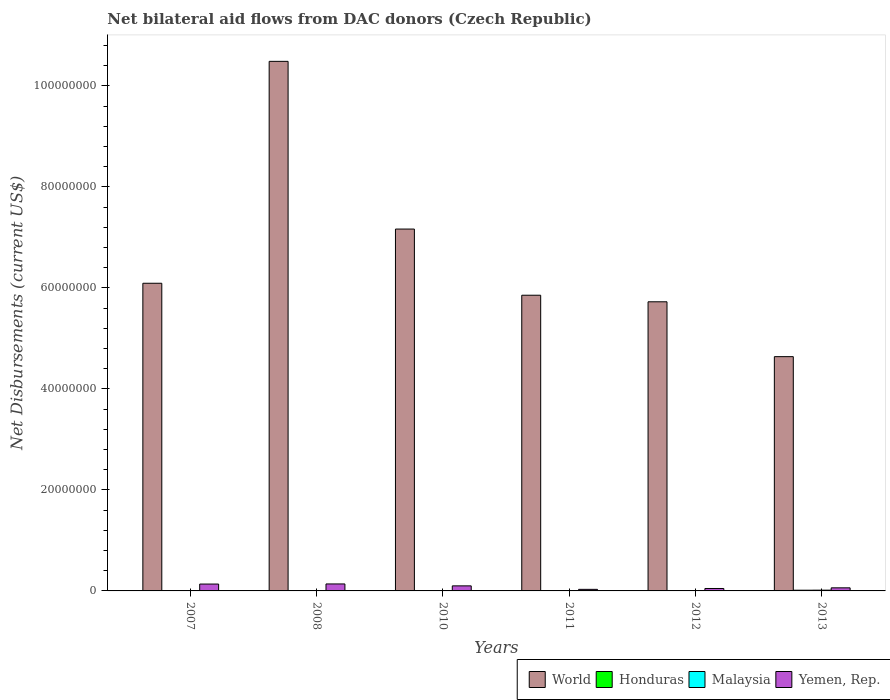How many groups of bars are there?
Give a very brief answer. 6. Are the number of bars per tick equal to the number of legend labels?
Your answer should be compact. Yes. How many bars are there on the 2nd tick from the left?
Keep it short and to the point. 4. How many bars are there on the 1st tick from the right?
Ensure brevity in your answer.  4. What is the label of the 2nd group of bars from the left?
Provide a short and direct response. 2008. In how many cases, is the number of bars for a given year not equal to the number of legend labels?
Your answer should be compact. 0. What is the net bilateral aid flows in World in 2010?
Offer a very short reply. 7.16e+07. Across all years, what is the maximum net bilateral aid flows in Yemen, Rep.?
Provide a short and direct response. 1.38e+06. Across all years, what is the minimum net bilateral aid flows in Yemen, Rep.?
Provide a succinct answer. 3.10e+05. What is the total net bilateral aid flows in Honduras in the graph?
Offer a terse response. 3.10e+05. What is the difference between the net bilateral aid flows in Yemen, Rep. in 2007 and the net bilateral aid flows in Honduras in 2012?
Your response must be concise. 1.34e+06. What is the average net bilateral aid flows in World per year?
Make the answer very short. 6.66e+07. In the year 2007, what is the difference between the net bilateral aid flows in Yemen, Rep. and net bilateral aid flows in Honduras?
Provide a short and direct response. 1.32e+06. In how many years, is the net bilateral aid flows in World greater than 12000000 US$?
Make the answer very short. 6. What is the ratio of the net bilateral aid flows in Malaysia in 2012 to that in 2013?
Offer a terse response. 0.33. Is the difference between the net bilateral aid flows in Yemen, Rep. in 2008 and 2012 greater than the difference between the net bilateral aid flows in Honduras in 2008 and 2012?
Offer a terse response. Yes. What is the difference between the highest and the lowest net bilateral aid flows in World?
Provide a succinct answer. 5.85e+07. Is the sum of the net bilateral aid flows in Honduras in 2010 and 2012 greater than the maximum net bilateral aid flows in Yemen, Rep. across all years?
Offer a very short reply. No. What does the 1st bar from the left in 2012 represents?
Make the answer very short. World. What does the 2nd bar from the right in 2012 represents?
Your response must be concise. Malaysia. How many bars are there?
Your answer should be compact. 24. How many years are there in the graph?
Offer a terse response. 6. What is the difference between two consecutive major ticks on the Y-axis?
Keep it short and to the point. 2.00e+07. Are the values on the major ticks of Y-axis written in scientific E-notation?
Make the answer very short. No. Does the graph contain any zero values?
Ensure brevity in your answer.  No. Does the graph contain grids?
Your answer should be compact. No. Where does the legend appear in the graph?
Your answer should be very brief. Bottom right. How are the legend labels stacked?
Ensure brevity in your answer.  Horizontal. What is the title of the graph?
Make the answer very short. Net bilateral aid flows from DAC donors (Czech Republic). What is the label or title of the X-axis?
Provide a succinct answer. Years. What is the label or title of the Y-axis?
Your answer should be compact. Net Disbursements (current US$). What is the Net Disbursements (current US$) in World in 2007?
Your answer should be very brief. 6.09e+07. What is the Net Disbursements (current US$) of Yemen, Rep. in 2007?
Give a very brief answer. 1.36e+06. What is the Net Disbursements (current US$) in World in 2008?
Offer a terse response. 1.05e+08. What is the Net Disbursements (current US$) in Yemen, Rep. in 2008?
Give a very brief answer. 1.38e+06. What is the Net Disbursements (current US$) of World in 2010?
Keep it short and to the point. 7.16e+07. What is the Net Disbursements (current US$) of Honduras in 2010?
Ensure brevity in your answer.  3.00e+04. What is the Net Disbursements (current US$) of Yemen, Rep. in 2010?
Your answer should be compact. 1.00e+06. What is the Net Disbursements (current US$) in World in 2011?
Offer a very short reply. 5.85e+07. What is the Net Disbursements (current US$) of Honduras in 2011?
Keep it short and to the point. 4.00e+04. What is the Net Disbursements (current US$) in Yemen, Rep. in 2011?
Give a very brief answer. 3.10e+05. What is the Net Disbursements (current US$) in World in 2012?
Your response must be concise. 5.72e+07. What is the Net Disbursements (current US$) of Yemen, Rep. in 2012?
Make the answer very short. 4.80e+05. What is the Net Disbursements (current US$) of World in 2013?
Your answer should be compact. 4.64e+07. What is the Net Disbursements (current US$) in Malaysia in 2013?
Keep it short and to the point. 1.50e+05. Across all years, what is the maximum Net Disbursements (current US$) of World?
Your answer should be very brief. 1.05e+08. Across all years, what is the maximum Net Disbursements (current US$) of Honduras?
Provide a short and direct response. 1.40e+05. Across all years, what is the maximum Net Disbursements (current US$) in Yemen, Rep.?
Provide a short and direct response. 1.38e+06. Across all years, what is the minimum Net Disbursements (current US$) of World?
Your answer should be very brief. 4.64e+07. Across all years, what is the minimum Net Disbursements (current US$) in Honduras?
Make the answer very short. 2.00e+04. Across all years, what is the minimum Net Disbursements (current US$) of Malaysia?
Your response must be concise. 2.00e+04. What is the total Net Disbursements (current US$) of World in the graph?
Your answer should be very brief. 4.00e+08. What is the total Net Disbursements (current US$) of Yemen, Rep. in the graph?
Ensure brevity in your answer.  5.14e+06. What is the difference between the Net Disbursements (current US$) of World in 2007 and that in 2008?
Provide a succinct answer. -4.39e+07. What is the difference between the Net Disbursements (current US$) in Honduras in 2007 and that in 2008?
Provide a short and direct response. 0. What is the difference between the Net Disbursements (current US$) of Malaysia in 2007 and that in 2008?
Make the answer very short. -10000. What is the difference between the Net Disbursements (current US$) in Yemen, Rep. in 2007 and that in 2008?
Offer a very short reply. -2.00e+04. What is the difference between the Net Disbursements (current US$) in World in 2007 and that in 2010?
Your answer should be compact. -1.07e+07. What is the difference between the Net Disbursements (current US$) in Honduras in 2007 and that in 2010?
Your answer should be very brief. 10000. What is the difference between the Net Disbursements (current US$) of Malaysia in 2007 and that in 2010?
Give a very brief answer. -4.00e+04. What is the difference between the Net Disbursements (current US$) of Yemen, Rep. in 2007 and that in 2010?
Your response must be concise. 3.60e+05. What is the difference between the Net Disbursements (current US$) in World in 2007 and that in 2011?
Your answer should be very brief. 2.37e+06. What is the difference between the Net Disbursements (current US$) of Yemen, Rep. in 2007 and that in 2011?
Keep it short and to the point. 1.05e+06. What is the difference between the Net Disbursements (current US$) of World in 2007 and that in 2012?
Offer a terse response. 3.67e+06. What is the difference between the Net Disbursements (current US$) in Malaysia in 2007 and that in 2012?
Provide a short and direct response. -3.00e+04. What is the difference between the Net Disbursements (current US$) of Yemen, Rep. in 2007 and that in 2012?
Offer a very short reply. 8.80e+05. What is the difference between the Net Disbursements (current US$) in World in 2007 and that in 2013?
Offer a very short reply. 1.45e+07. What is the difference between the Net Disbursements (current US$) in Malaysia in 2007 and that in 2013?
Provide a succinct answer. -1.30e+05. What is the difference between the Net Disbursements (current US$) in Yemen, Rep. in 2007 and that in 2013?
Provide a succinct answer. 7.50e+05. What is the difference between the Net Disbursements (current US$) of World in 2008 and that in 2010?
Ensure brevity in your answer.  3.32e+07. What is the difference between the Net Disbursements (current US$) in Honduras in 2008 and that in 2010?
Keep it short and to the point. 10000. What is the difference between the Net Disbursements (current US$) of World in 2008 and that in 2011?
Give a very brief answer. 4.63e+07. What is the difference between the Net Disbursements (current US$) of Malaysia in 2008 and that in 2011?
Keep it short and to the point. -3.00e+04. What is the difference between the Net Disbursements (current US$) in Yemen, Rep. in 2008 and that in 2011?
Offer a very short reply. 1.07e+06. What is the difference between the Net Disbursements (current US$) in World in 2008 and that in 2012?
Keep it short and to the point. 4.76e+07. What is the difference between the Net Disbursements (current US$) of Malaysia in 2008 and that in 2012?
Your response must be concise. -2.00e+04. What is the difference between the Net Disbursements (current US$) of Yemen, Rep. in 2008 and that in 2012?
Ensure brevity in your answer.  9.00e+05. What is the difference between the Net Disbursements (current US$) of World in 2008 and that in 2013?
Offer a terse response. 5.85e+07. What is the difference between the Net Disbursements (current US$) in Honduras in 2008 and that in 2013?
Ensure brevity in your answer.  -1.00e+05. What is the difference between the Net Disbursements (current US$) in Yemen, Rep. in 2008 and that in 2013?
Offer a terse response. 7.70e+05. What is the difference between the Net Disbursements (current US$) in World in 2010 and that in 2011?
Your response must be concise. 1.31e+07. What is the difference between the Net Disbursements (current US$) of Yemen, Rep. in 2010 and that in 2011?
Your answer should be compact. 6.90e+05. What is the difference between the Net Disbursements (current US$) in World in 2010 and that in 2012?
Your response must be concise. 1.44e+07. What is the difference between the Net Disbursements (current US$) of Honduras in 2010 and that in 2012?
Provide a succinct answer. 10000. What is the difference between the Net Disbursements (current US$) in Malaysia in 2010 and that in 2012?
Your answer should be compact. 10000. What is the difference between the Net Disbursements (current US$) of Yemen, Rep. in 2010 and that in 2012?
Ensure brevity in your answer.  5.20e+05. What is the difference between the Net Disbursements (current US$) of World in 2010 and that in 2013?
Provide a succinct answer. 2.53e+07. What is the difference between the Net Disbursements (current US$) of Honduras in 2010 and that in 2013?
Ensure brevity in your answer.  -1.10e+05. What is the difference between the Net Disbursements (current US$) in World in 2011 and that in 2012?
Provide a short and direct response. 1.30e+06. What is the difference between the Net Disbursements (current US$) of Honduras in 2011 and that in 2012?
Offer a very short reply. 2.00e+04. What is the difference between the Net Disbursements (current US$) in World in 2011 and that in 2013?
Provide a succinct answer. 1.22e+07. What is the difference between the Net Disbursements (current US$) of Malaysia in 2011 and that in 2013?
Your response must be concise. -9.00e+04. What is the difference between the Net Disbursements (current US$) of Yemen, Rep. in 2011 and that in 2013?
Your answer should be compact. -3.00e+05. What is the difference between the Net Disbursements (current US$) of World in 2012 and that in 2013?
Ensure brevity in your answer.  1.09e+07. What is the difference between the Net Disbursements (current US$) of Honduras in 2012 and that in 2013?
Provide a succinct answer. -1.20e+05. What is the difference between the Net Disbursements (current US$) of Malaysia in 2012 and that in 2013?
Offer a terse response. -1.00e+05. What is the difference between the Net Disbursements (current US$) in World in 2007 and the Net Disbursements (current US$) in Honduras in 2008?
Give a very brief answer. 6.09e+07. What is the difference between the Net Disbursements (current US$) of World in 2007 and the Net Disbursements (current US$) of Malaysia in 2008?
Your response must be concise. 6.09e+07. What is the difference between the Net Disbursements (current US$) in World in 2007 and the Net Disbursements (current US$) in Yemen, Rep. in 2008?
Provide a succinct answer. 5.95e+07. What is the difference between the Net Disbursements (current US$) in Honduras in 2007 and the Net Disbursements (current US$) in Yemen, Rep. in 2008?
Offer a very short reply. -1.34e+06. What is the difference between the Net Disbursements (current US$) in Malaysia in 2007 and the Net Disbursements (current US$) in Yemen, Rep. in 2008?
Offer a very short reply. -1.36e+06. What is the difference between the Net Disbursements (current US$) of World in 2007 and the Net Disbursements (current US$) of Honduras in 2010?
Your response must be concise. 6.09e+07. What is the difference between the Net Disbursements (current US$) of World in 2007 and the Net Disbursements (current US$) of Malaysia in 2010?
Offer a very short reply. 6.08e+07. What is the difference between the Net Disbursements (current US$) in World in 2007 and the Net Disbursements (current US$) in Yemen, Rep. in 2010?
Your answer should be very brief. 5.99e+07. What is the difference between the Net Disbursements (current US$) in Honduras in 2007 and the Net Disbursements (current US$) in Malaysia in 2010?
Give a very brief answer. -2.00e+04. What is the difference between the Net Disbursements (current US$) in Honduras in 2007 and the Net Disbursements (current US$) in Yemen, Rep. in 2010?
Provide a succinct answer. -9.60e+05. What is the difference between the Net Disbursements (current US$) in Malaysia in 2007 and the Net Disbursements (current US$) in Yemen, Rep. in 2010?
Your response must be concise. -9.80e+05. What is the difference between the Net Disbursements (current US$) of World in 2007 and the Net Disbursements (current US$) of Honduras in 2011?
Ensure brevity in your answer.  6.09e+07. What is the difference between the Net Disbursements (current US$) of World in 2007 and the Net Disbursements (current US$) of Malaysia in 2011?
Your answer should be compact. 6.08e+07. What is the difference between the Net Disbursements (current US$) of World in 2007 and the Net Disbursements (current US$) of Yemen, Rep. in 2011?
Give a very brief answer. 6.06e+07. What is the difference between the Net Disbursements (current US$) of World in 2007 and the Net Disbursements (current US$) of Honduras in 2012?
Give a very brief answer. 6.09e+07. What is the difference between the Net Disbursements (current US$) of World in 2007 and the Net Disbursements (current US$) of Malaysia in 2012?
Offer a very short reply. 6.09e+07. What is the difference between the Net Disbursements (current US$) of World in 2007 and the Net Disbursements (current US$) of Yemen, Rep. in 2012?
Your answer should be very brief. 6.04e+07. What is the difference between the Net Disbursements (current US$) in Honduras in 2007 and the Net Disbursements (current US$) in Malaysia in 2012?
Provide a short and direct response. -10000. What is the difference between the Net Disbursements (current US$) of Honduras in 2007 and the Net Disbursements (current US$) of Yemen, Rep. in 2012?
Your answer should be compact. -4.40e+05. What is the difference between the Net Disbursements (current US$) in Malaysia in 2007 and the Net Disbursements (current US$) in Yemen, Rep. in 2012?
Your answer should be very brief. -4.60e+05. What is the difference between the Net Disbursements (current US$) of World in 2007 and the Net Disbursements (current US$) of Honduras in 2013?
Offer a very short reply. 6.08e+07. What is the difference between the Net Disbursements (current US$) of World in 2007 and the Net Disbursements (current US$) of Malaysia in 2013?
Give a very brief answer. 6.08e+07. What is the difference between the Net Disbursements (current US$) of World in 2007 and the Net Disbursements (current US$) of Yemen, Rep. in 2013?
Offer a terse response. 6.03e+07. What is the difference between the Net Disbursements (current US$) of Honduras in 2007 and the Net Disbursements (current US$) of Malaysia in 2013?
Keep it short and to the point. -1.10e+05. What is the difference between the Net Disbursements (current US$) in Honduras in 2007 and the Net Disbursements (current US$) in Yemen, Rep. in 2013?
Your response must be concise. -5.70e+05. What is the difference between the Net Disbursements (current US$) of Malaysia in 2007 and the Net Disbursements (current US$) of Yemen, Rep. in 2013?
Offer a terse response. -5.90e+05. What is the difference between the Net Disbursements (current US$) of World in 2008 and the Net Disbursements (current US$) of Honduras in 2010?
Your answer should be compact. 1.05e+08. What is the difference between the Net Disbursements (current US$) in World in 2008 and the Net Disbursements (current US$) in Malaysia in 2010?
Your response must be concise. 1.05e+08. What is the difference between the Net Disbursements (current US$) of World in 2008 and the Net Disbursements (current US$) of Yemen, Rep. in 2010?
Your response must be concise. 1.04e+08. What is the difference between the Net Disbursements (current US$) in Honduras in 2008 and the Net Disbursements (current US$) in Malaysia in 2010?
Offer a terse response. -2.00e+04. What is the difference between the Net Disbursements (current US$) of Honduras in 2008 and the Net Disbursements (current US$) of Yemen, Rep. in 2010?
Ensure brevity in your answer.  -9.60e+05. What is the difference between the Net Disbursements (current US$) of Malaysia in 2008 and the Net Disbursements (current US$) of Yemen, Rep. in 2010?
Give a very brief answer. -9.70e+05. What is the difference between the Net Disbursements (current US$) in World in 2008 and the Net Disbursements (current US$) in Honduras in 2011?
Provide a succinct answer. 1.05e+08. What is the difference between the Net Disbursements (current US$) of World in 2008 and the Net Disbursements (current US$) of Malaysia in 2011?
Provide a short and direct response. 1.05e+08. What is the difference between the Net Disbursements (current US$) of World in 2008 and the Net Disbursements (current US$) of Yemen, Rep. in 2011?
Offer a terse response. 1.05e+08. What is the difference between the Net Disbursements (current US$) in Honduras in 2008 and the Net Disbursements (current US$) in Malaysia in 2011?
Provide a succinct answer. -2.00e+04. What is the difference between the Net Disbursements (current US$) of Malaysia in 2008 and the Net Disbursements (current US$) of Yemen, Rep. in 2011?
Your answer should be very brief. -2.80e+05. What is the difference between the Net Disbursements (current US$) of World in 2008 and the Net Disbursements (current US$) of Honduras in 2012?
Ensure brevity in your answer.  1.05e+08. What is the difference between the Net Disbursements (current US$) of World in 2008 and the Net Disbursements (current US$) of Malaysia in 2012?
Provide a short and direct response. 1.05e+08. What is the difference between the Net Disbursements (current US$) of World in 2008 and the Net Disbursements (current US$) of Yemen, Rep. in 2012?
Give a very brief answer. 1.04e+08. What is the difference between the Net Disbursements (current US$) in Honduras in 2008 and the Net Disbursements (current US$) in Malaysia in 2012?
Your answer should be compact. -10000. What is the difference between the Net Disbursements (current US$) of Honduras in 2008 and the Net Disbursements (current US$) of Yemen, Rep. in 2012?
Make the answer very short. -4.40e+05. What is the difference between the Net Disbursements (current US$) in Malaysia in 2008 and the Net Disbursements (current US$) in Yemen, Rep. in 2012?
Ensure brevity in your answer.  -4.50e+05. What is the difference between the Net Disbursements (current US$) in World in 2008 and the Net Disbursements (current US$) in Honduras in 2013?
Keep it short and to the point. 1.05e+08. What is the difference between the Net Disbursements (current US$) of World in 2008 and the Net Disbursements (current US$) of Malaysia in 2013?
Offer a terse response. 1.05e+08. What is the difference between the Net Disbursements (current US$) of World in 2008 and the Net Disbursements (current US$) of Yemen, Rep. in 2013?
Make the answer very short. 1.04e+08. What is the difference between the Net Disbursements (current US$) in Honduras in 2008 and the Net Disbursements (current US$) in Yemen, Rep. in 2013?
Your answer should be compact. -5.70e+05. What is the difference between the Net Disbursements (current US$) of Malaysia in 2008 and the Net Disbursements (current US$) of Yemen, Rep. in 2013?
Keep it short and to the point. -5.80e+05. What is the difference between the Net Disbursements (current US$) of World in 2010 and the Net Disbursements (current US$) of Honduras in 2011?
Provide a short and direct response. 7.16e+07. What is the difference between the Net Disbursements (current US$) of World in 2010 and the Net Disbursements (current US$) of Malaysia in 2011?
Your response must be concise. 7.16e+07. What is the difference between the Net Disbursements (current US$) in World in 2010 and the Net Disbursements (current US$) in Yemen, Rep. in 2011?
Ensure brevity in your answer.  7.13e+07. What is the difference between the Net Disbursements (current US$) of Honduras in 2010 and the Net Disbursements (current US$) of Malaysia in 2011?
Provide a short and direct response. -3.00e+04. What is the difference between the Net Disbursements (current US$) of Honduras in 2010 and the Net Disbursements (current US$) of Yemen, Rep. in 2011?
Keep it short and to the point. -2.80e+05. What is the difference between the Net Disbursements (current US$) of World in 2010 and the Net Disbursements (current US$) of Honduras in 2012?
Offer a terse response. 7.16e+07. What is the difference between the Net Disbursements (current US$) in World in 2010 and the Net Disbursements (current US$) in Malaysia in 2012?
Offer a terse response. 7.16e+07. What is the difference between the Net Disbursements (current US$) of World in 2010 and the Net Disbursements (current US$) of Yemen, Rep. in 2012?
Provide a succinct answer. 7.12e+07. What is the difference between the Net Disbursements (current US$) of Honduras in 2010 and the Net Disbursements (current US$) of Malaysia in 2012?
Provide a short and direct response. -2.00e+04. What is the difference between the Net Disbursements (current US$) of Honduras in 2010 and the Net Disbursements (current US$) of Yemen, Rep. in 2012?
Your answer should be compact. -4.50e+05. What is the difference between the Net Disbursements (current US$) in Malaysia in 2010 and the Net Disbursements (current US$) in Yemen, Rep. in 2012?
Keep it short and to the point. -4.20e+05. What is the difference between the Net Disbursements (current US$) of World in 2010 and the Net Disbursements (current US$) of Honduras in 2013?
Your answer should be compact. 7.15e+07. What is the difference between the Net Disbursements (current US$) of World in 2010 and the Net Disbursements (current US$) of Malaysia in 2013?
Offer a terse response. 7.15e+07. What is the difference between the Net Disbursements (current US$) in World in 2010 and the Net Disbursements (current US$) in Yemen, Rep. in 2013?
Offer a terse response. 7.10e+07. What is the difference between the Net Disbursements (current US$) in Honduras in 2010 and the Net Disbursements (current US$) in Yemen, Rep. in 2013?
Your response must be concise. -5.80e+05. What is the difference between the Net Disbursements (current US$) in Malaysia in 2010 and the Net Disbursements (current US$) in Yemen, Rep. in 2013?
Make the answer very short. -5.50e+05. What is the difference between the Net Disbursements (current US$) in World in 2011 and the Net Disbursements (current US$) in Honduras in 2012?
Provide a succinct answer. 5.85e+07. What is the difference between the Net Disbursements (current US$) of World in 2011 and the Net Disbursements (current US$) of Malaysia in 2012?
Keep it short and to the point. 5.85e+07. What is the difference between the Net Disbursements (current US$) of World in 2011 and the Net Disbursements (current US$) of Yemen, Rep. in 2012?
Your response must be concise. 5.81e+07. What is the difference between the Net Disbursements (current US$) in Honduras in 2011 and the Net Disbursements (current US$) in Malaysia in 2012?
Provide a succinct answer. -10000. What is the difference between the Net Disbursements (current US$) in Honduras in 2011 and the Net Disbursements (current US$) in Yemen, Rep. in 2012?
Provide a short and direct response. -4.40e+05. What is the difference between the Net Disbursements (current US$) in Malaysia in 2011 and the Net Disbursements (current US$) in Yemen, Rep. in 2012?
Ensure brevity in your answer.  -4.20e+05. What is the difference between the Net Disbursements (current US$) of World in 2011 and the Net Disbursements (current US$) of Honduras in 2013?
Keep it short and to the point. 5.84e+07. What is the difference between the Net Disbursements (current US$) in World in 2011 and the Net Disbursements (current US$) in Malaysia in 2013?
Give a very brief answer. 5.84e+07. What is the difference between the Net Disbursements (current US$) in World in 2011 and the Net Disbursements (current US$) in Yemen, Rep. in 2013?
Keep it short and to the point. 5.79e+07. What is the difference between the Net Disbursements (current US$) of Honduras in 2011 and the Net Disbursements (current US$) of Malaysia in 2013?
Offer a very short reply. -1.10e+05. What is the difference between the Net Disbursements (current US$) of Honduras in 2011 and the Net Disbursements (current US$) of Yemen, Rep. in 2013?
Give a very brief answer. -5.70e+05. What is the difference between the Net Disbursements (current US$) in Malaysia in 2011 and the Net Disbursements (current US$) in Yemen, Rep. in 2013?
Your answer should be compact. -5.50e+05. What is the difference between the Net Disbursements (current US$) in World in 2012 and the Net Disbursements (current US$) in Honduras in 2013?
Your response must be concise. 5.71e+07. What is the difference between the Net Disbursements (current US$) in World in 2012 and the Net Disbursements (current US$) in Malaysia in 2013?
Make the answer very short. 5.71e+07. What is the difference between the Net Disbursements (current US$) in World in 2012 and the Net Disbursements (current US$) in Yemen, Rep. in 2013?
Your answer should be compact. 5.66e+07. What is the difference between the Net Disbursements (current US$) of Honduras in 2012 and the Net Disbursements (current US$) of Malaysia in 2013?
Keep it short and to the point. -1.30e+05. What is the difference between the Net Disbursements (current US$) of Honduras in 2012 and the Net Disbursements (current US$) of Yemen, Rep. in 2013?
Provide a succinct answer. -5.90e+05. What is the difference between the Net Disbursements (current US$) in Malaysia in 2012 and the Net Disbursements (current US$) in Yemen, Rep. in 2013?
Provide a succinct answer. -5.60e+05. What is the average Net Disbursements (current US$) of World per year?
Ensure brevity in your answer.  6.66e+07. What is the average Net Disbursements (current US$) in Honduras per year?
Your answer should be compact. 5.17e+04. What is the average Net Disbursements (current US$) in Malaysia per year?
Offer a very short reply. 6.17e+04. What is the average Net Disbursements (current US$) in Yemen, Rep. per year?
Provide a short and direct response. 8.57e+05. In the year 2007, what is the difference between the Net Disbursements (current US$) in World and Net Disbursements (current US$) in Honduras?
Offer a very short reply. 6.09e+07. In the year 2007, what is the difference between the Net Disbursements (current US$) in World and Net Disbursements (current US$) in Malaysia?
Your response must be concise. 6.09e+07. In the year 2007, what is the difference between the Net Disbursements (current US$) of World and Net Disbursements (current US$) of Yemen, Rep.?
Offer a terse response. 5.96e+07. In the year 2007, what is the difference between the Net Disbursements (current US$) in Honduras and Net Disbursements (current US$) in Malaysia?
Your answer should be compact. 2.00e+04. In the year 2007, what is the difference between the Net Disbursements (current US$) of Honduras and Net Disbursements (current US$) of Yemen, Rep.?
Ensure brevity in your answer.  -1.32e+06. In the year 2007, what is the difference between the Net Disbursements (current US$) of Malaysia and Net Disbursements (current US$) of Yemen, Rep.?
Give a very brief answer. -1.34e+06. In the year 2008, what is the difference between the Net Disbursements (current US$) in World and Net Disbursements (current US$) in Honduras?
Your answer should be very brief. 1.05e+08. In the year 2008, what is the difference between the Net Disbursements (current US$) in World and Net Disbursements (current US$) in Malaysia?
Your answer should be very brief. 1.05e+08. In the year 2008, what is the difference between the Net Disbursements (current US$) in World and Net Disbursements (current US$) in Yemen, Rep.?
Offer a terse response. 1.03e+08. In the year 2008, what is the difference between the Net Disbursements (current US$) of Honduras and Net Disbursements (current US$) of Malaysia?
Your answer should be compact. 10000. In the year 2008, what is the difference between the Net Disbursements (current US$) of Honduras and Net Disbursements (current US$) of Yemen, Rep.?
Offer a very short reply. -1.34e+06. In the year 2008, what is the difference between the Net Disbursements (current US$) in Malaysia and Net Disbursements (current US$) in Yemen, Rep.?
Your response must be concise. -1.35e+06. In the year 2010, what is the difference between the Net Disbursements (current US$) of World and Net Disbursements (current US$) of Honduras?
Provide a short and direct response. 7.16e+07. In the year 2010, what is the difference between the Net Disbursements (current US$) in World and Net Disbursements (current US$) in Malaysia?
Your answer should be very brief. 7.16e+07. In the year 2010, what is the difference between the Net Disbursements (current US$) in World and Net Disbursements (current US$) in Yemen, Rep.?
Your answer should be very brief. 7.06e+07. In the year 2010, what is the difference between the Net Disbursements (current US$) in Honduras and Net Disbursements (current US$) in Malaysia?
Make the answer very short. -3.00e+04. In the year 2010, what is the difference between the Net Disbursements (current US$) in Honduras and Net Disbursements (current US$) in Yemen, Rep.?
Make the answer very short. -9.70e+05. In the year 2010, what is the difference between the Net Disbursements (current US$) of Malaysia and Net Disbursements (current US$) of Yemen, Rep.?
Offer a very short reply. -9.40e+05. In the year 2011, what is the difference between the Net Disbursements (current US$) of World and Net Disbursements (current US$) of Honduras?
Keep it short and to the point. 5.85e+07. In the year 2011, what is the difference between the Net Disbursements (current US$) in World and Net Disbursements (current US$) in Malaysia?
Provide a short and direct response. 5.85e+07. In the year 2011, what is the difference between the Net Disbursements (current US$) in World and Net Disbursements (current US$) in Yemen, Rep.?
Provide a succinct answer. 5.82e+07. In the year 2011, what is the difference between the Net Disbursements (current US$) in Honduras and Net Disbursements (current US$) in Malaysia?
Your answer should be compact. -2.00e+04. In the year 2011, what is the difference between the Net Disbursements (current US$) of Malaysia and Net Disbursements (current US$) of Yemen, Rep.?
Your response must be concise. -2.50e+05. In the year 2012, what is the difference between the Net Disbursements (current US$) of World and Net Disbursements (current US$) of Honduras?
Offer a terse response. 5.72e+07. In the year 2012, what is the difference between the Net Disbursements (current US$) of World and Net Disbursements (current US$) of Malaysia?
Your answer should be very brief. 5.72e+07. In the year 2012, what is the difference between the Net Disbursements (current US$) of World and Net Disbursements (current US$) of Yemen, Rep.?
Offer a very short reply. 5.68e+07. In the year 2012, what is the difference between the Net Disbursements (current US$) in Honduras and Net Disbursements (current US$) in Yemen, Rep.?
Provide a succinct answer. -4.60e+05. In the year 2012, what is the difference between the Net Disbursements (current US$) in Malaysia and Net Disbursements (current US$) in Yemen, Rep.?
Keep it short and to the point. -4.30e+05. In the year 2013, what is the difference between the Net Disbursements (current US$) in World and Net Disbursements (current US$) in Honduras?
Keep it short and to the point. 4.62e+07. In the year 2013, what is the difference between the Net Disbursements (current US$) in World and Net Disbursements (current US$) in Malaysia?
Offer a terse response. 4.62e+07. In the year 2013, what is the difference between the Net Disbursements (current US$) of World and Net Disbursements (current US$) of Yemen, Rep.?
Keep it short and to the point. 4.58e+07. In the year 2013, what is the difference between the Net Disbursements (current US$) in Honduras and Net Disbursements (current US$) in Malaysia?
Keep it short and to the point. -10000. In the year 2013, what is the difference between the Net Disbursements (current US$) of Honduras and Net Disbursements (current US$) of Yemen, Rep.?
Ensure brevity in your answer.  -4.70e+05. In the year 2013, what is the difference between the Net Disbursements (current US$) in Malaysia and Net Disbursements (current US$) in Yemen, Rep.?
Make the answer very short. -4.60e+05. What is the ratio of the Net Disbursements (current US$) in World in 2007 to that in 2008?
Ensure brevity in your answer.  0.58. What is the ratio of the Net Disbursements (current US$) of Honduras in 2007 to that in 2008?
Ensure brevity in your answer.  1. What is the ratio of the Net Disbursements (current US$) of Malaysia in 2007 to that in 2008?
Your response must be concise. 0.67. What is the ratio of the Net Disbursements (current US$) of Yemen, Rep. in 2007 to that in 2008?
Give a very brief answer. 0.99. What is the ratio of the Net Disbursements (current US$) in World in 2007 to that in 2010?
Your answer should be very brief. 0.85. What is the ratio of the Net Disbursements (current US$) of Honduras in 2007 to that in 2010?
Your answer should be very brief. 1.33. What is the ratio of the Net Disbursements (current US$) of Yemen, Rep. in 2007 to that in 2010?
Provide a short and direct response. 1.36. What is the ratio of the Net Disbursements (current US$) of World in 2007 to that in 2011?
Give a very brief answer. 1.04. What is the ratio of the Net Disbursements (current US$) of Malaysia in 2007 to that in 2011?
Your answer should be compact. 0.33. What is the ratio of the Net Disbursements (current US$) of Yemen, Rep. in 2007 to that in 2011?
Ensure brevity in your answer.  4.39. What is the ratio of the Net Disbursements (current US$) of World in 2007 to that in 2012?
Your response must be concise. 1.06. What is the ratio of the Net Disbursements (current US$) in Honduras in 2007 to that in 2012?
Provide a short and direct response. 2. What is the ratio of the Net Disbursements (current US$) in Yemen, Rep. in 2007 to that in 2012?
Keep it short and to the point. 2.83. What is the ratio of the Net Disbursements (current US$) of World in 2007 to that in 2013?
Offer a terse response. 1.31. What is the ratio of the Net Disbursements (current US$) in Honduras in 2007 to that in 2013?
Your answer should be compact. 0.29. What is the ratio of the Net Disbursements (current US$) in Malaysia in 2007 to that in 2013?
Your answer should be very brief. 0.13. What is the ratio of the Net Disbursements (current US$) in Yemen, Rep. in 2007 to that in 2013?
Provide a short and direct response. 2.23. What is the ratio of the Net Disbursements (current US$) in World in 2008 to that in 2010?
Your answer should be compact. 1.46. What is the ratio of the Net Disbursements (current US$) in Malaysia in 2008 to that in 2010?
Offer a terse response. 0.5. What is the ratio of the Net Disbursements (current US$) in Yemen, Rep. in 2008 to that in 2010?
Provide a succinct answer. 1.38. What is the ratio of the Net Disbursements (current US$) of World in 2008 to that in 2011?
Your response must be concise. 1.79. What is the ratio of the Net Disbursements (current US$) in Malaysia in 2008 to that in 2011?
Offer a very short reply. 0.5. What is the ratio of the Net Disbursements (current US$) of Yemen, Rep. in 2008 to that in 2011?
Give a very brief answer. 4.45. What is the ratio of the Net Disbursements (current US$) in World in 2008 to that in 2012?
Ensure brevity in your answer.  1.83. What is the ratio of the Net Disbursements (current US$) of Malaysia in 2008 to that in 2012?
Your answer should be compact. 0.6. What is the ratio of the Net Disbursements (current US$) in Yemen, Rep. in 2008 to that in 2012?
Your answer should be compact. 2.88. What is the ratio of the Net Disbursements (current US$) in World in 2008 to that in 2013?
Your answer should be compact. 2.26. What is the ratio of the Net Disbursements (current US$) of Honduras in 2008 to that in 2013?
Offer a very short reply. 0.29. What is the ratio of the Net Disbursements (current US$) in Yemen, Rep. in 2008 to that in 2013?
Keep it short and to the point. 2.26. What is the ratio of the Net Disbursements (current US$) in World in 2010 to that in 2011?
Your answer should be very brief. 1.22. What is the ratio of the Net Disbursements (current US$) of Malaysia in 2010 to that in 2011?
Your response must be concise. 1. What is the ratio of the Net Disbursements (current US$) of Yemen, Rep. in 2010 to that in 2011?
Offer a very short reply. 3.23. What is the ratio of the Net Disbursements (current US$) in World in 2010 to that in 2012?
Offer a terse response. 1.25. What is the ratio of the Net Disbursements (current US$) of Honduras in 2010 to that in 2012?
Your answer should be very brief. 1.5. What is the ratio of the Net Disbursements (current US$) of Malaysia in 2010 to that in 2012?
Offer a very short reply. 1.2. What is the ratio of the Net Disbursements (current US$) of Yemen, Rep. in 2010 to that in 2012?
Keep it short and to the point. 2.08. What is the ratio of the Net Disbursements (current US$) in World in 2010 to that in 2013?
Ensure brevity in your answer.  1.54. What is the ratio of the Net Disbursements (current US$) in Honduras in 2010 to that in 2013?
Give a very brief answer. 0.21. What is the ratio of the Net Disbursements (current US$) of Yemen, Rep. in 2010 to that in 2013?
Your response must be concise. 1.64. What is the ratio of the Net Disbursements (current US$) of World in 2011 to that in 2012?
Make the answer very short. 1.02. What is the ratio of the Net Disbursements (current US$) in Yemen, Rep. in 2011 to that in 2012?
Keep it short and to the point. 0.65. What is the ratio of the Net Disbursements (current US$) in World in 2011 to that in 2013?
Make the answer very short. 1.26. What is the ratio of the Net Disbursements (current US$) in Honduras in 2011 to that in 2013?
Your answer should be compact. 0.29. What is the ratio of the Net Disbursements (current US$) in Yemen, Rep. in 2011 to that in 2013?
Offer a terse response. 0.51. What is the ratio of the Net Disbursements (current US$) of World in 2012 to that in 2013?
Your answer should be very brief. 1.23. What is the ratio of the Net Disbursements (current US$) in Honduras in 2012 to that in 2013?
Offer a terse response. 0.14. What is the ratio of the Net Disbursements (current US$) in Yemen, Rep. in 2012 to that in 2013?
Give a very brief answer. 0.79. What is the difference between the highest and the second highest Net Disbursements (current US$) of World?
Offer a very short reply. 3.32e+07. What is the difference between the highest and the second highest Net Disbursements (current US$) in Honduras?
Your response must be concise. 1.00e+05. What is the difference between the highest and the lowest Net Disbursements (current US$) of World?
Provide a succinct answer. 5.85e+07. What is the difference between the highest and the lowest Net Disbursements (current US$) of Yemen, Rep.?
Make the answer very short. 1.07e+06. 